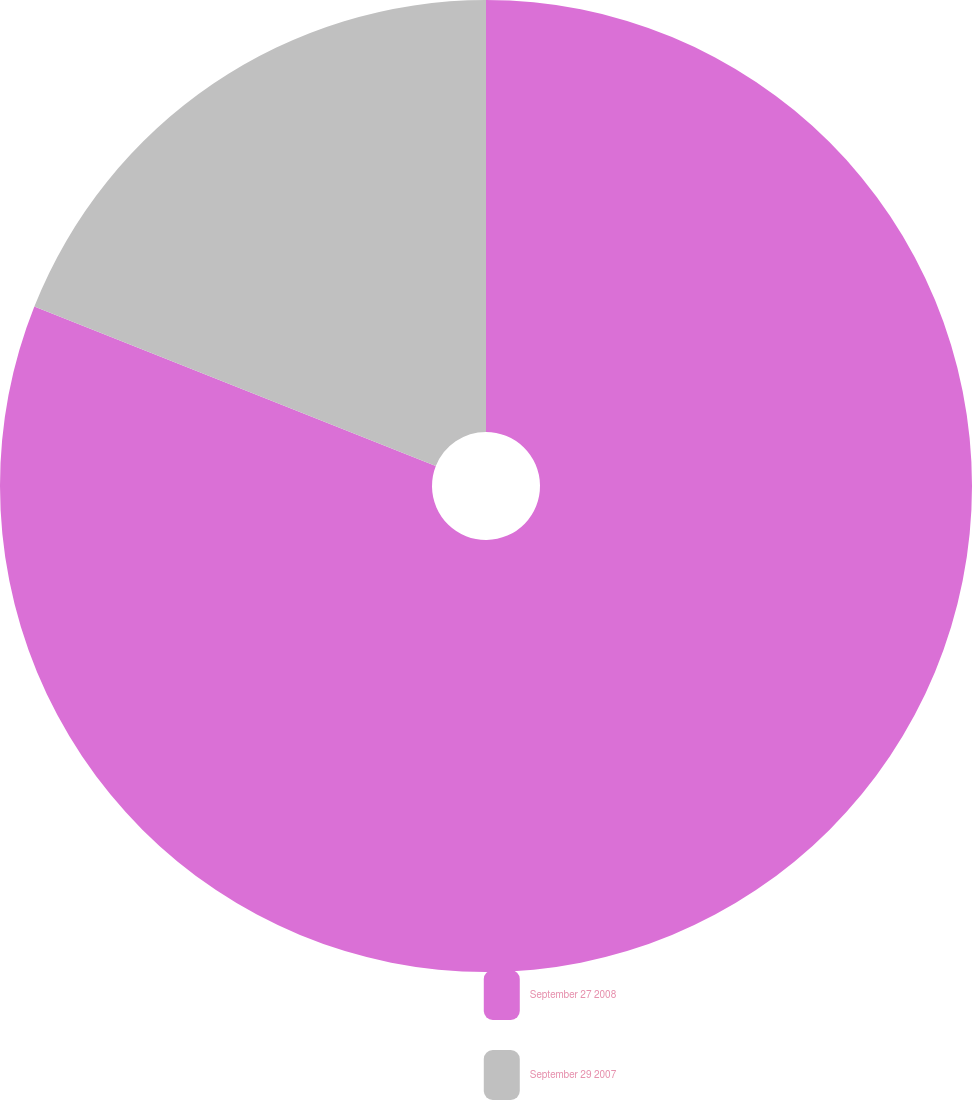Convert chart to OTSL. <chart><loc_0><loc_0><loc_500><loc_500><pie_chart><fcel>September 27 2008<fcel>September 29 2007<nl><fcel>81.02%<fcel>18.98%<nl></chart> 